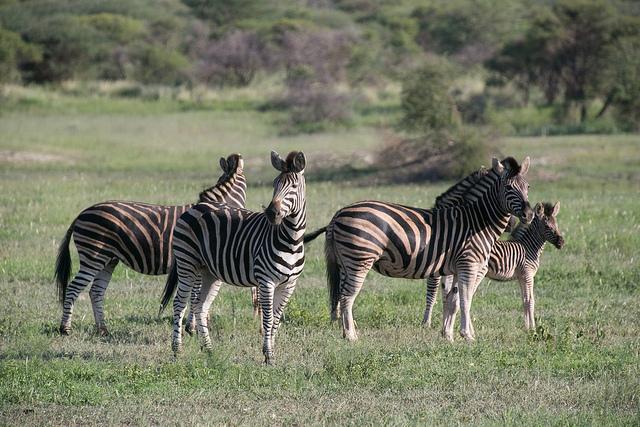How many zebras are present?
Write a very short answer. 4. Where is the antelope?
Short answer required. No antelope. How many stripes are on each zebra?
Answer briefly. 999. Where are the zebras standing?
Short answer required. Field. How many zebras are resting?
Answer briefly. 0. Do the zebra a colorful pattern?
Quick response, please. No. Are these animals grazing?
Give a very brief answer. No. What is the color of the zebra?
Write a very short answer. Black and white. 